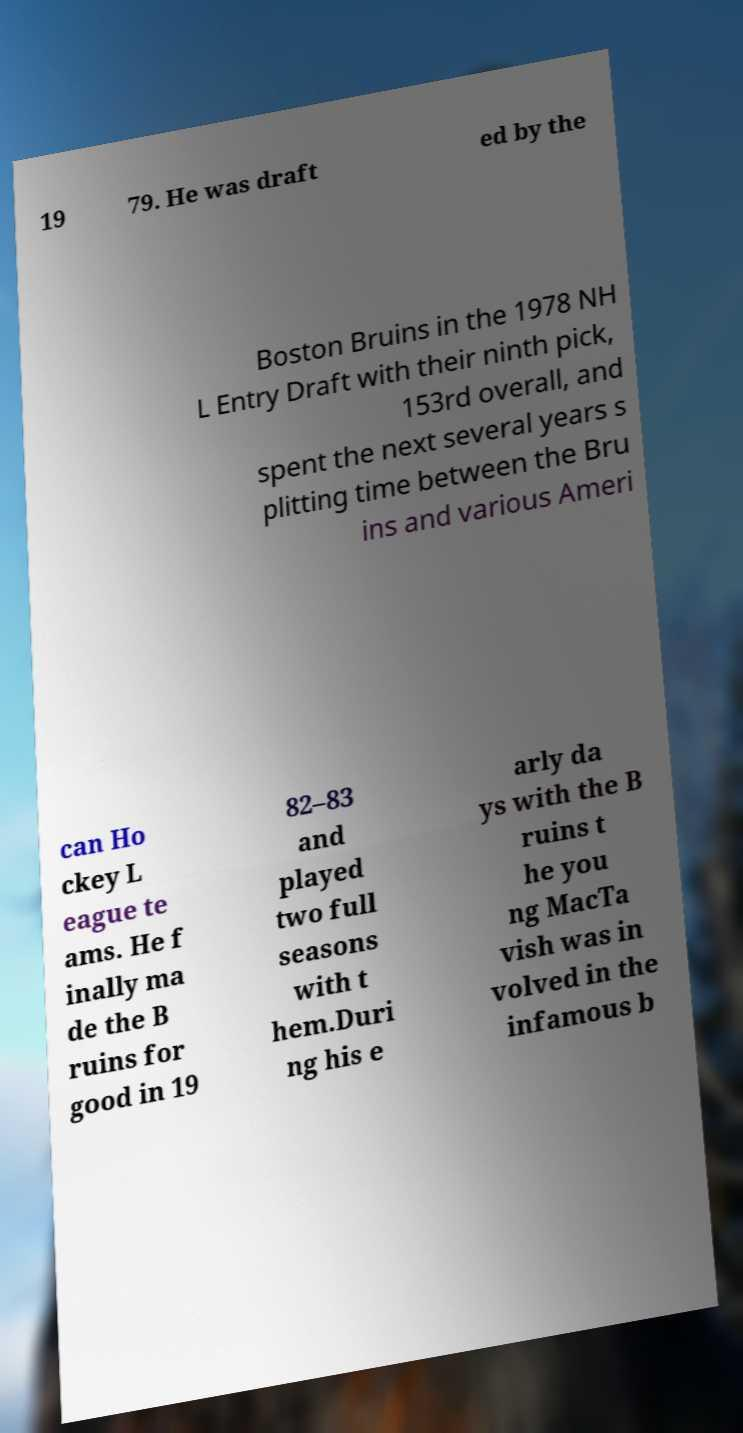I need the written content from this picture converted into text. Can you do that? 19 79. He was draft ed by the Boston Bruins in the 1978 NH L Entry Draft with their ninth pick, 153rd overall, and spent the next several years s plitting time between the Bru ins and various Ameri can Ho ckey L eague te ams. He f inally ma de the B ruins for good in 19 82–83 and played two full seasons with t hem.Duri ng his e arly da ys with the B ruins t he you ng MacTa vish was in volved in the infamous b 